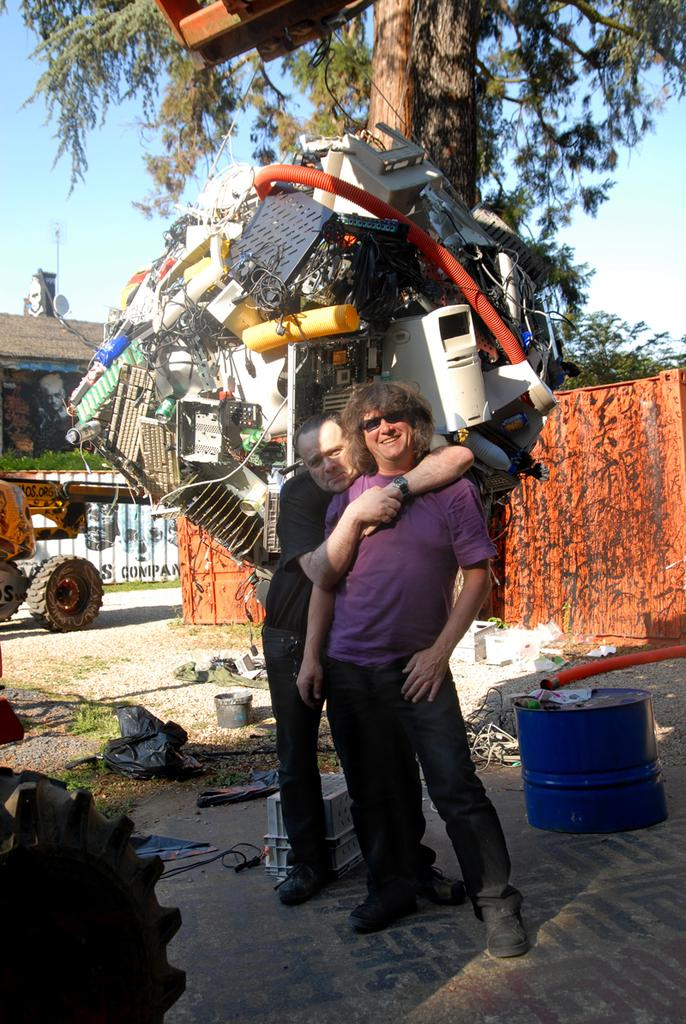What can be seen in the image regarding human figures? There are men standing in the image. What is the surface on which the men are standing? The men are standing on the floor. What type of artwork is present in the image? There is a sculpture made with scrap in the image. What type of natural elements can be seen in the image? Trees are present in the image. What type of man-made objects are visible in the image? Motor vehicles are visible in the image. What type of structures can be seen in the image? There are sheds in the image. What part of the natural environment is visible in the image? The sky is visible in the image. What type of salt is being used to season the men's food in the image? There is no indication of food or seasoning in the image, so it is not possible to determine if salt is being used. --- Facts: 1. There is a person sitting on a chair in the image. 2. The person is holding a book. 3. The book has a blue cover. 4. There is a table next to the chair. 5. The table has a lamp on it. 6. The lamp has a red shade. Absurd Topics: elephant, ocean, bicycle Conversation: What is the person in the image doing? The person is sitting on a chair in the image. What object is the person holding? The person is holding a book. What is the color of the book's cover? The book has a blue cover. What piece of furniture is next to the chair? There is a table next to the chair. What object is on the table? The table has a lamp on it. What is the color of the lamp's shade? The lamp has a red shade. Reasoning: Let's think step by step in order to produce the conversation. We start by identifying the main subject in the image, which is the person sitting on a chair. Then, we expand the conversation to include other items that are also visible, such as the book, the table, and the lamp. Each question is designed to elicit a specific detail about the image that is known from the provided facts. Absurd Question/Answer: Can you see an elephant swimming in the ocean in the image? No, there is no elephant or ocean present in the image. 